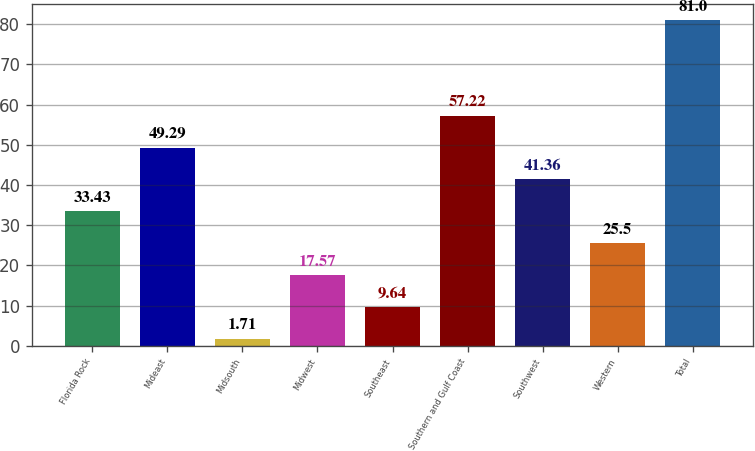Convert chart. <chart><loc_0><loc_0><loc_500><loc_500><bar_chart><fcel>Florida Rock<fcel>Mideast<fcel>Midsouth<fcel>Midwest<fcel>Southeast<fcel>Southern and Gulf Coast<fcel>Southwest<fcel>Western<fcel>Total<nl><fcel>33.43<fcel>49.29<fcel>1.71<fcel>17.57<fcel>9.64<fcel>57.22<fcel>41.36<fcel>25.5<fcel>81<nl></chart> 